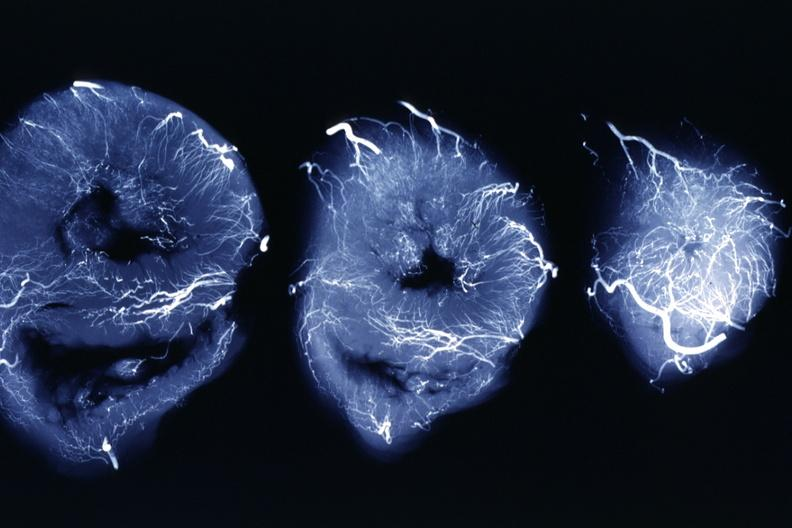s coronary artery anomalous origin left from pulmonary artery present?
Answer the question using a single word or phrase. No 